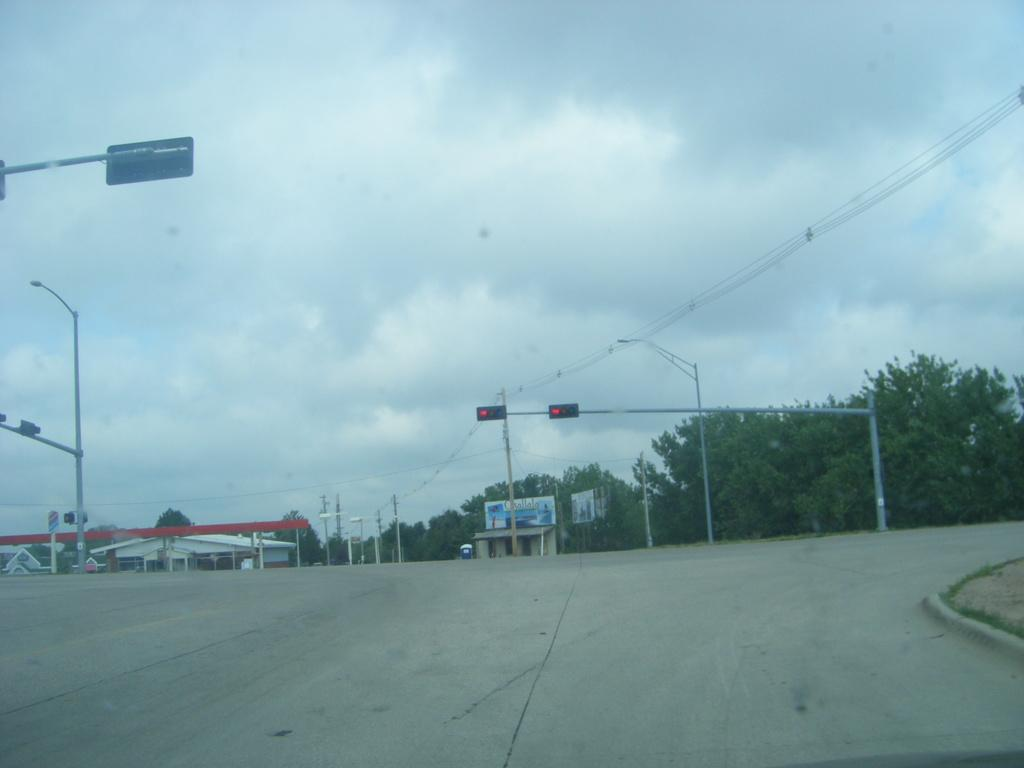What structures can be seen in the image? There are poles and traffic signals in the image. What type of vegetation is present in the image? There are trees and grass in the image. What type of buildings can be seen in the image? There are houses in the image. What is the condition of the sky in the background of the image? The sky appears to be cloudy in the background of the image. Can you tell me how many people are thrilled by the push of the whip in the image? There are no people or whips present in the image; it features poles, traffic signals, trees, houses, a road, grass, and a cloudy sky. 